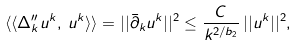<formula> <loc_0><loc_0><loc_500><loc_500>\langle \langle \Delta _ { k } ^ { \prime \prime } u ^ { k } , \, u ^ { k } \rangle \rangle = | | \bar { \partial } _ { k } u ^ { k } | | ^ { 2 } \leq \frac { C } { k ^ { 2 / b _ { 2 } } } \, | | u ^ { k } | | ^ { 2 } ,</formula> 